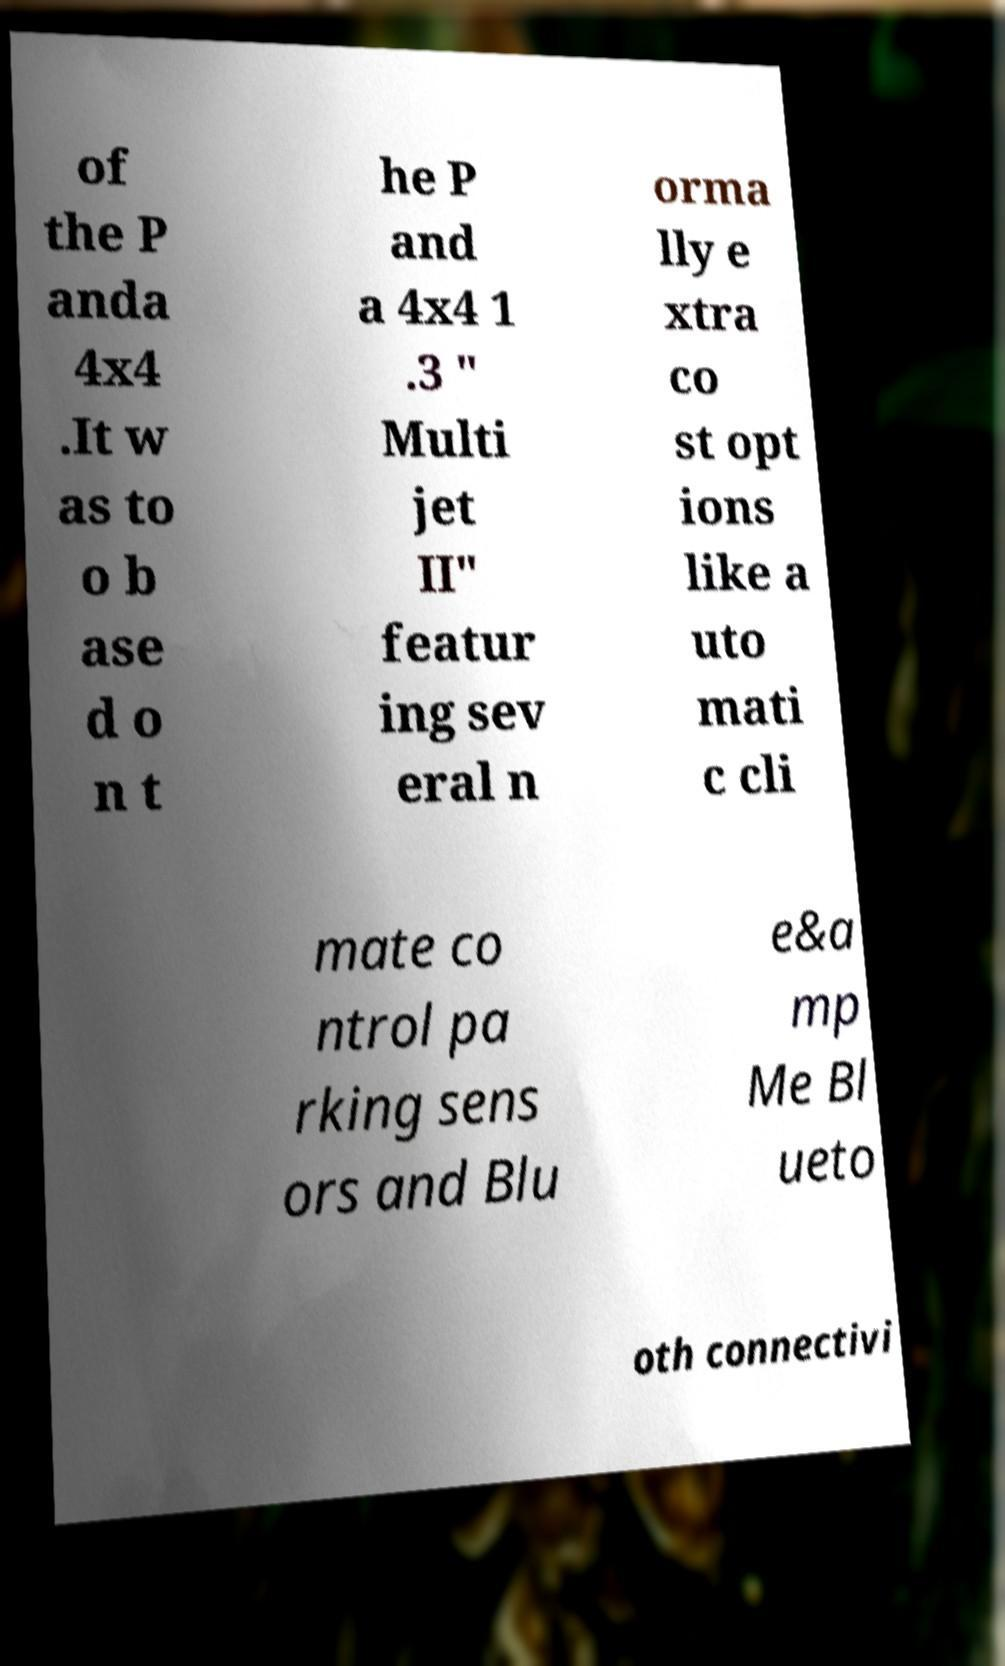Can you read and provide the text displayed in the image?This photo seems to have some interesting text. Can you extract and type it out for me? of the P anda 4x4 .It w as to o b ase d o n t he P and a 4x4 1 .3 " Multi jet II" featur ing sev eral n orma lly e xtra co st opt ions like a uto mati c cli mate co ntrol pa rking sens ors and Blu e&a mp Me Bl ueto oth connectivi 